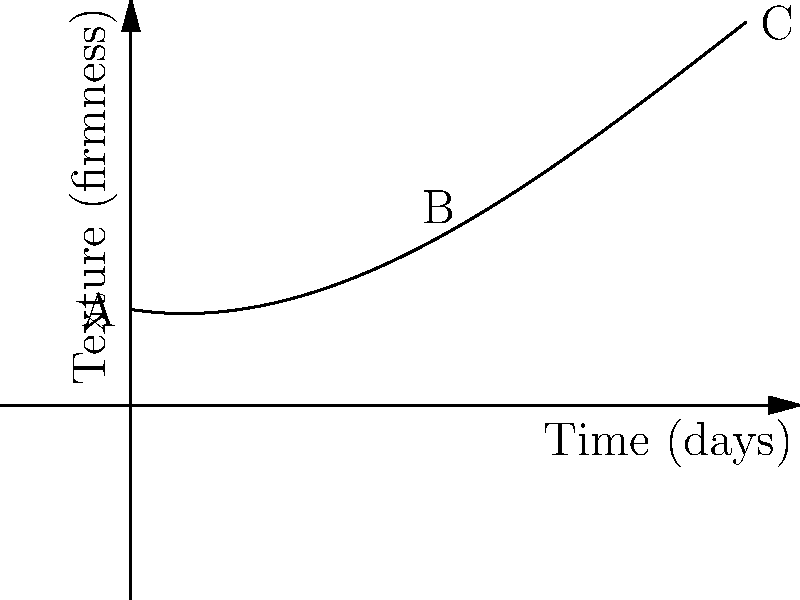As a documentary filmmaker studying the fermentation process of a traditional cheese, you've plotted the texture changes over time. The graph shows the cheese's firmness (y-axis) against the fermentation time in days (x-axis). If the polynomial function representing this graph is $f(x) = -0.01x^3 + 0.3x^2 - 0.5x + 5$, what is the rate of change in texture at day 5 (point B)? To find the rate of change at day 5, we need to follow these steps:

1) The rate of change at any point is given by the derivative of the function at that point.

2) First, let's find the derivative of $f(x) = -0.01x^3 + 0.3x^2 - 0.5x + 5$:
   $f'(x) = -0.03x^2 + 0.6x - 0.5$

3) Now, we need to evaluate this derivative at x = 5:
   $f'(5) = -0.03(5^2) + 0.6(5) - 0.5$
   
4) Let's calculate step by step:
   $f'(5) = -0.03(25) + 3 - 0.5$
   $f'(5) = -0.75 + 3 - 0.5$
   $f'(5) = 1.75$

5) Therefore, the rate of change at day 5 is 1.75 units of firmness per day.
Answer: 1.75 units/day 